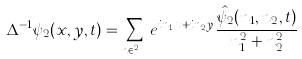Convert formula to latex. <formula><loc_0><loc_0><loc_500><loc_500>\Delta ^ { - 1 } \psi _ { 2 } ( x , y , t ) = \sum _ { n \in \mathbb { Z } ^ { 2 } } e ^ { i n _ { 1 } x + i n _ { 2 } y } \frac { \hat { \psi _ { 2 } } ( n _ { 1 } , n _ { 2 } , t ) } { n _ { 1 } ^ { 2 } + n _ { 2 } ^ { 2 } }</formula> 